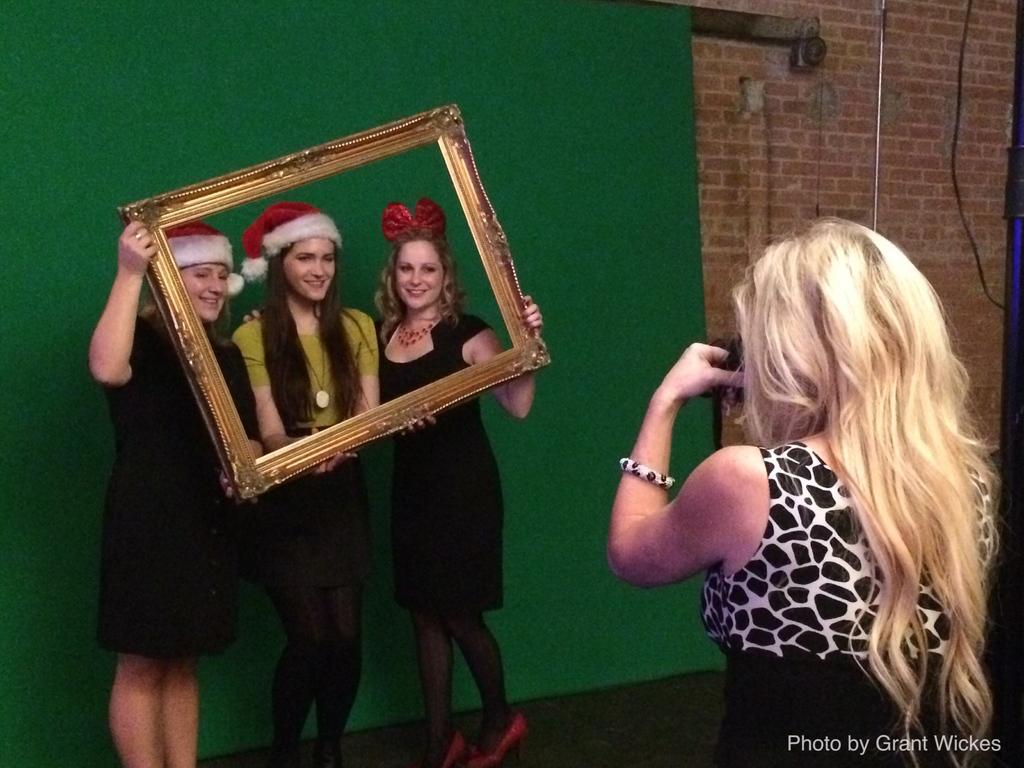Could you give a brief overview of what you see in this image? This picture is clicked inside. On the right there is a woman wearing black color dress standing on the ground and seems to be taking pictures. On the left we can see the group of three women smiling, holding a golden color frame and standing on the ground. In the background there is a green color curtain, brick wall, cable and a metal rod. At the bottom right corner there is a text on the image. 